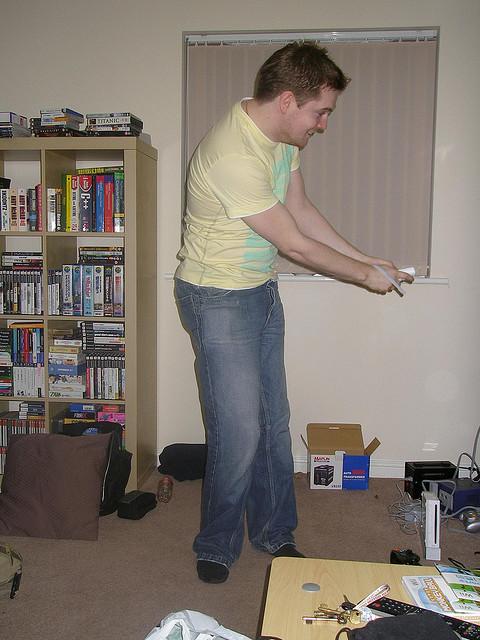What is on the floor?
Answer briefly. Box. Does this man have a food in his mouth?
Quick response, please. No. What is the color of the men's top?
Answer briefly. Yellow. What is written on the pieces of paper?
Be succinct. Words. What is the space used for?
Keep it brief. Play games. Where are the man's feet?
Answer briefly. Floor. What is the child's name?
Answer briefly. Jeff. Is the man wearing glasses?
Concise answer only. No. What kind of blinds are on the window?
Give a very brief answer. Vertical. What's the floor made of?
Quick response, please. Carpet. How many people are playing Wii?
Give a very brief answer. 1. Does he have a drink in his hand?
Concise answer only. No. What game is the man playing?
Give a very brief answer. Wii. Is the man on his laptop?
Concise answer only. No. What color is the man's shirt?
Be succinct. Yellow. Is this man wearing socks?
Be succinct. Yes. Do you see chairs?
Give a very brief answer. No. Are there any eyeglasses?
Keep it brief. No. 